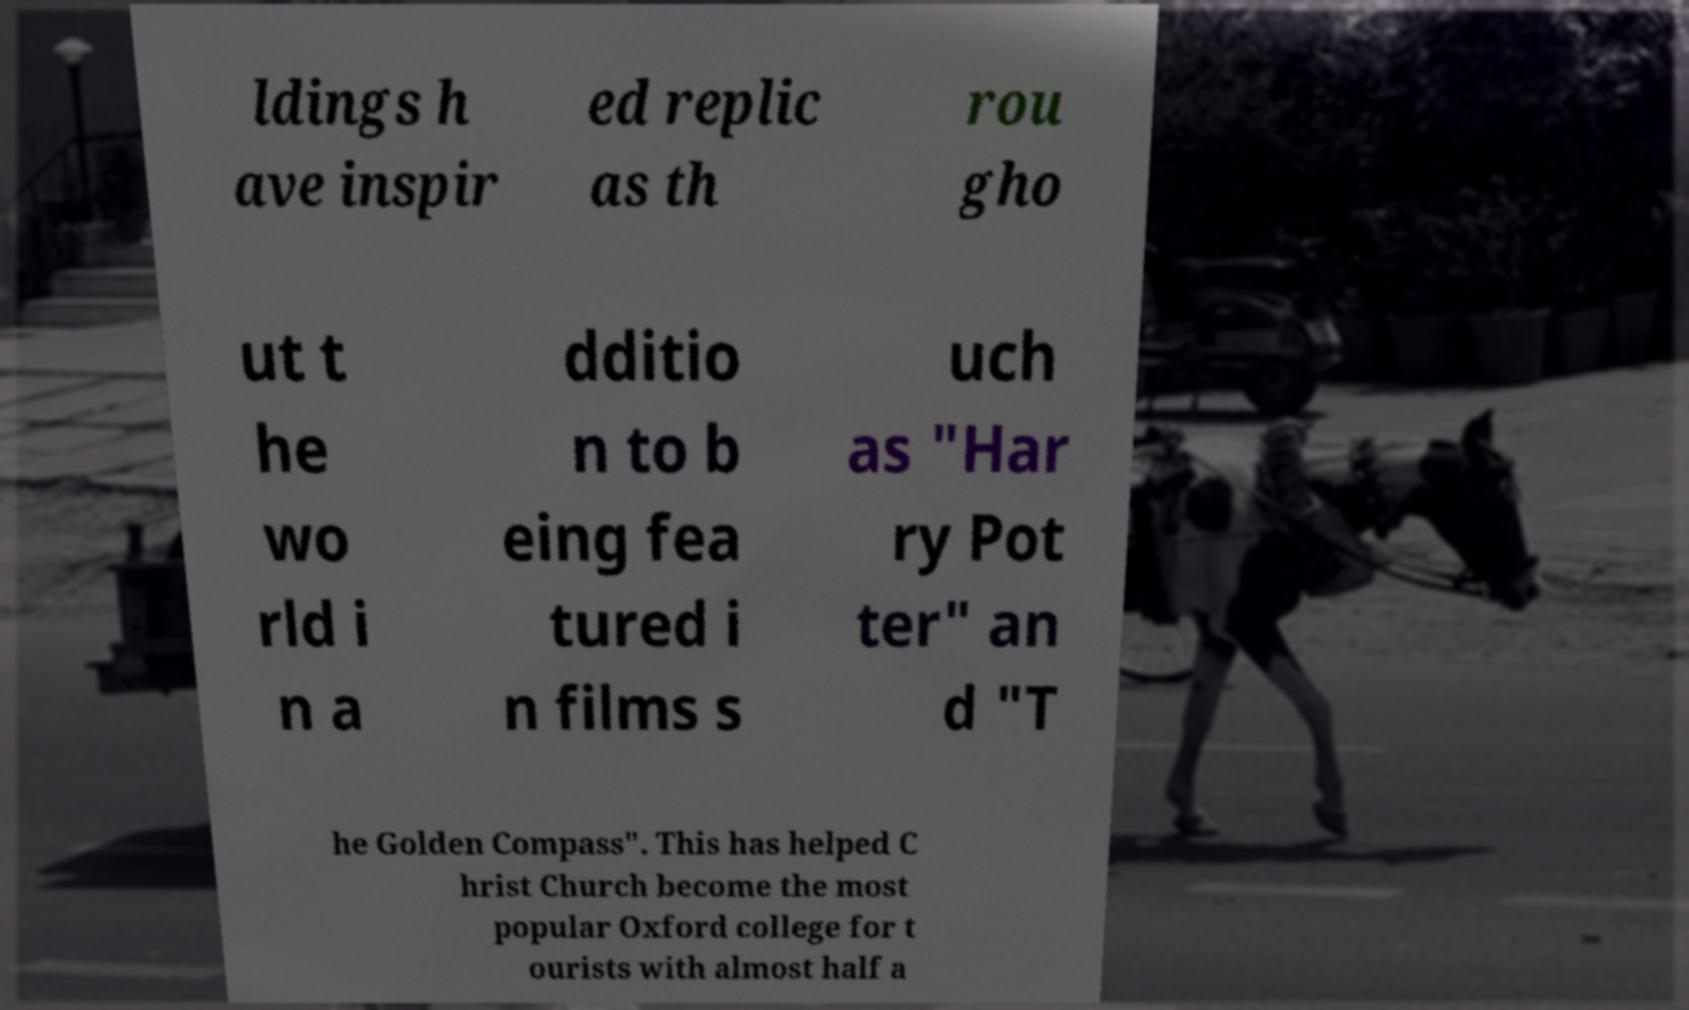What messages or text are displayed in this image? I need them in a readable, typed format. ldings h ave inspir ed replic as th rou gho ut t he wo rld i n a dditio n to b eing fea tured i n films s uch as "Har ry Pot ter" an d "T he Golden Compass". This has helped C hrist Church become the most popular Oxford college for t ourists with almost half a 